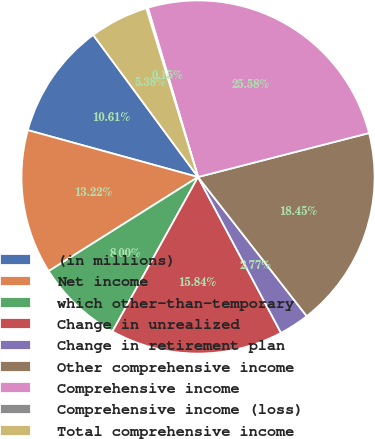Convert chart. <chart><loc_0><loc_0><loc_500><loc_500><pie_chart><fcel>(in millions)<fcel>Net income<fcel>which other-than-temporary<fcel>Change in unrealized<fcel>Change in retirement plan<fcel>Other comprehensive income<fcel>Comprehensive income<fcel>Comprehensive income (loss)<fcel>Total comprehensive income<nl><fcel>10.61%<fcel>13.22%<fcel>8.0%<fcel>15.84%<fcel>2.77%<fcel>18.45%<fcel>25.58%<fcel>0.15%<fcel>5.38%<nl></chart> 